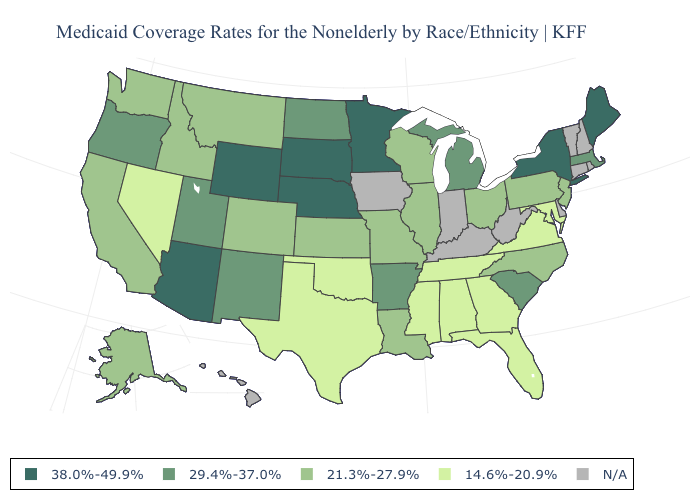What is the highest value in states that border Utah?
Be succinct. 38.0%-49.9%. What is the value of Oregon?
Short answer required. 29.4%-37.0%. What is the lowest value in the West?
Give a very brief answer. 14.6%-20.9%. Among the states that border Delaware , does Maryland have the highest value?
Short answer required. No. Name the states that have a value in the range 29.4%-37.0%?
Answer briefly. Arkansas, Massachusetts, Michigan, New Mexico, North Dakota, Oregon, South Carolina, Utah. Name the states that have a value in the range 38.0%-49.9%?
Short answer required. Arizona, Maine, Minnesota, Nebraska, New York, South Dakota, Wyoming. Does Nevada have the lowest value in the West?
Concise answer only. Yes. Does the map have missing data?
Short answer required. Yes. Does Minnesota have the highest value in the USA?
Be succinct. Yes. What is the value of Florida?
Write a very short answer. 14.6%-20.9%. What is the lowest value in the South?
Quick response, please. 14.6%-20.9%. Which states have the lowest value in the USA?
Keep it brief. Alabama, Florida, Georgia, Maryland, Mississippi, Nevada, Oklahoma, Tennessee, Texas, Virginia. Does New Jersey have the lowest value in the Northeast?
Short answer required. Yes. Name the states that have a value in the range 21.3%-27.9%?
Be succinct. Alaska, California, Colorado, Idaho, Illinois, Kansas, Louisiana, Missouri, Montana, New Jersey, North Carolina, Ohio, Pennsylvania, Washington, Wisconsin. 